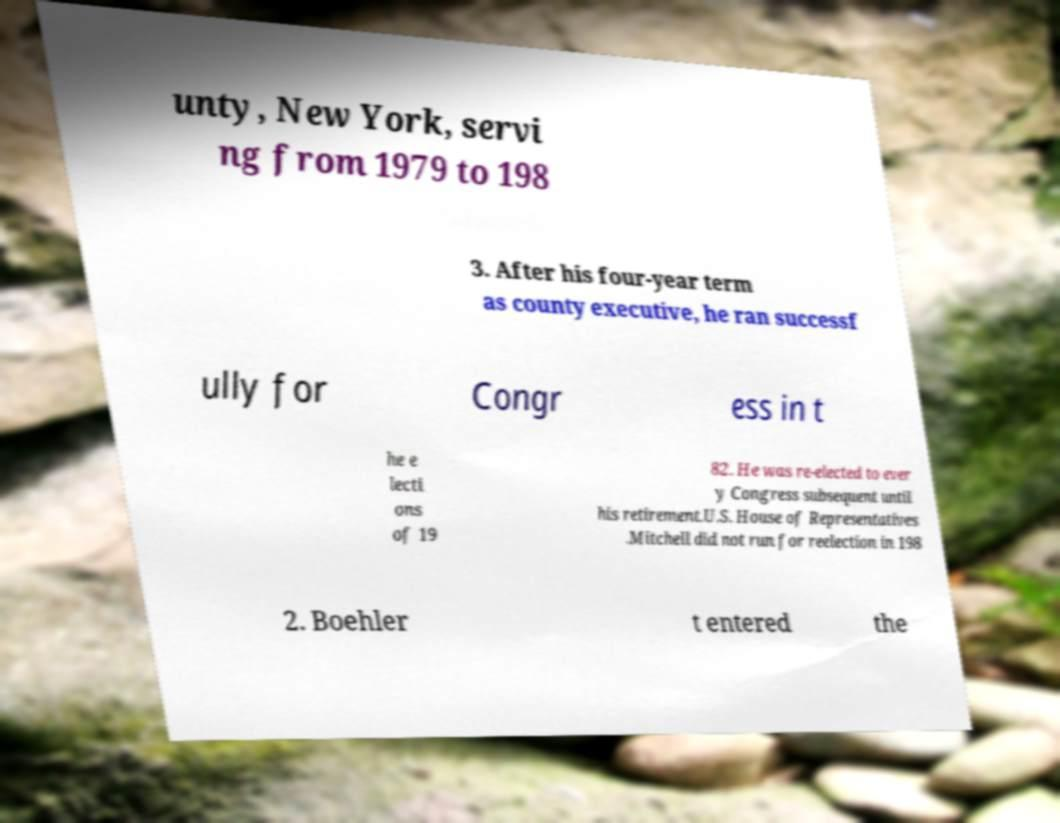Could you extract and type out the text from this image? The text from the image appears partially blurred and difficult to read in full, but I can decipher the following portions: 'unty, New York, servi ng from 1979 to 198 3. As county executive, he ran successfully for Congr ess in t he e lecti ons of 19 82. He was re-elected to ever y Congress subsequent until his retirement.U.S. House of Representatives. Mitchell did not run for reelection in 198 2. Boehler tent ered the'. It appears to discuss political careers, possibly referencing service years of an individual in Congress and local government roles. 